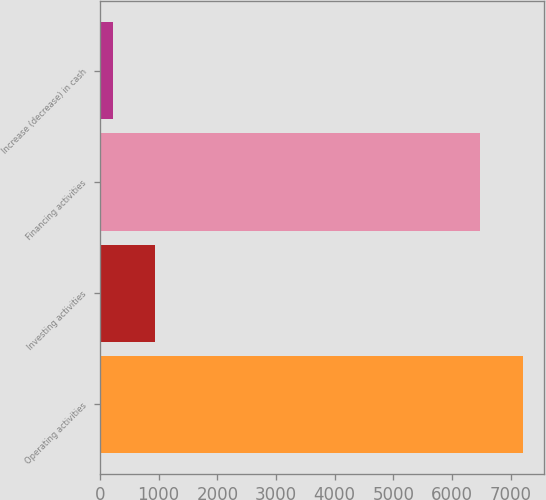Convert chart to OTSL. <chart><loc_0><loc_0><loc_500><loc_500><bar_chart><fcel>Operating activities<fcel>Investing activities<fcel>Financing activities<fcel>Increase (decrease) in cash<nl><fcel>7205<fcel>941<fcel>6478<fcel>215<nl></chart> 